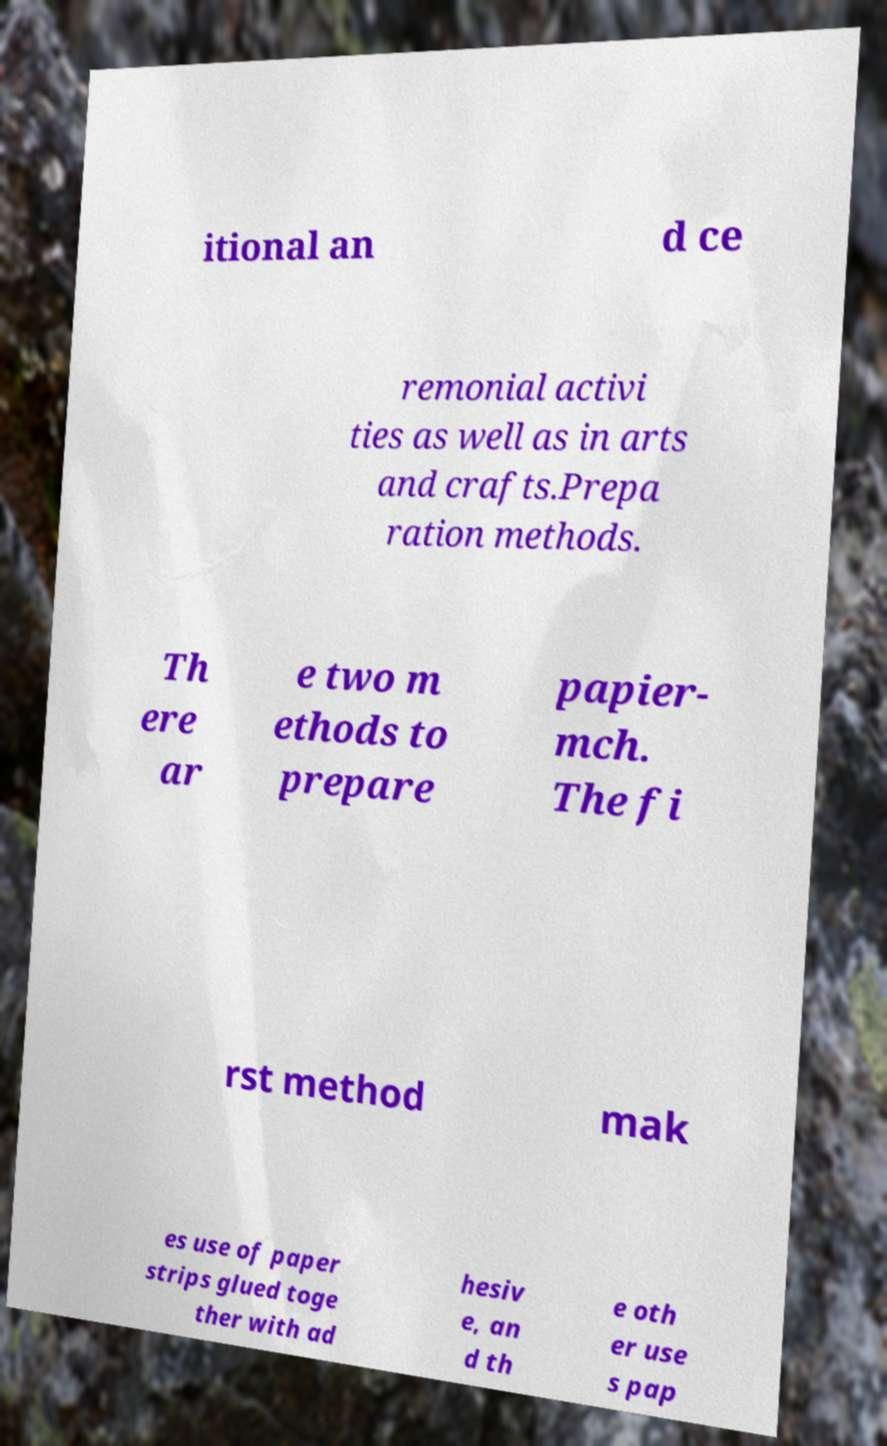Can you read and provide the text displayed in the image?This photo seems to have some interesting text. Can you extract and type it out for me? itional an d ce remonial activi ties as well as in arts and crafts.Prepa ration methods. Th ere ar e two m ethods to prepare papier- mch. The fi rst method mak es use of paper strips glued toge ther with ad hesiv e, an d th e oth er use s pap 